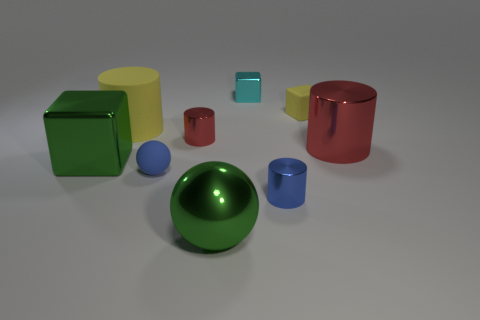There is a red object that is the same size as the yellow cube; what is its shape?
Give a very brief answer. Cylinder. What number of big things are green metal spheres or green metallic objects?
Keep it short and to the point. 2. There is a tiny metallic cylinder left of the metal thing behind the small matte block; are there any shiny blocks that are behind it?
Make the answer very short. Yes. Are there any blue metal balls of the same size as the blue metallic cylinder?
Your answer should be very brief. No. What material is the yellow block that is the same size as the blue sphere?
Your response must be concise. Rubber. Do the yellow matte cylinder and the green object in front of the blue matte thing have the same size?
Provide a succinct answer. Yes. What number of rubber things are purple cubes or cyan cubes?
Keep it short and to the point. 0. How many other large things have the same shape as the cyan metal thing?
Offer a very short reply. 1. There is a object that is the same color as the tiny rubber cube; what is it made of?
Keep it short and to the point. Rubber. There is a green object to the left of the yellow matte cylinder; is it the same size as the green metallic object that is in front of the large green metallic block?
Your answer should be compact. Yes. 